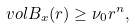<formula> <loc_0><loc_0><loc_500><loc_500>v o l B _ { x } ( r ) \geq \nu _ { 0 } r ^ { n } ,</formula> 